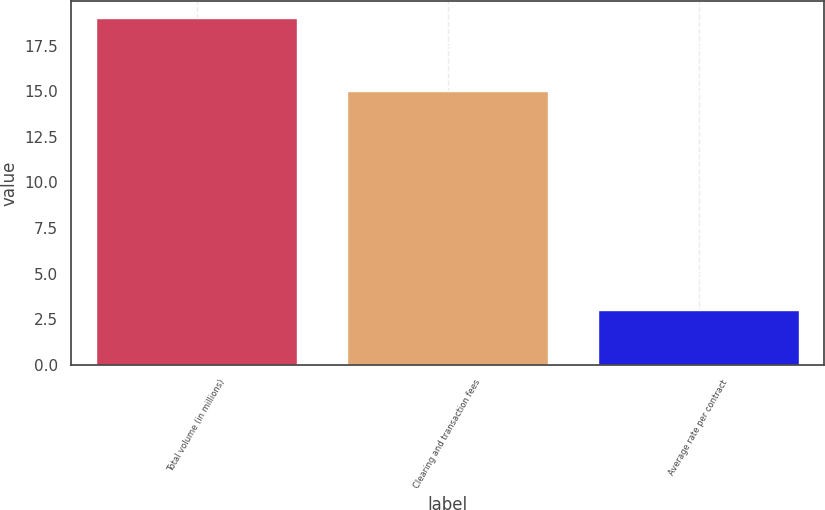Convert chart to OTSL. <chart><loc_0><loc_0><loc_500><loc_500><bar_chart><fcel>Total volume (in millions)<fcel>Clearing and transaction fees<fcel>Average rate per contract<nl><fcel>19<fcel>15<fcel>3<nl></chart> 